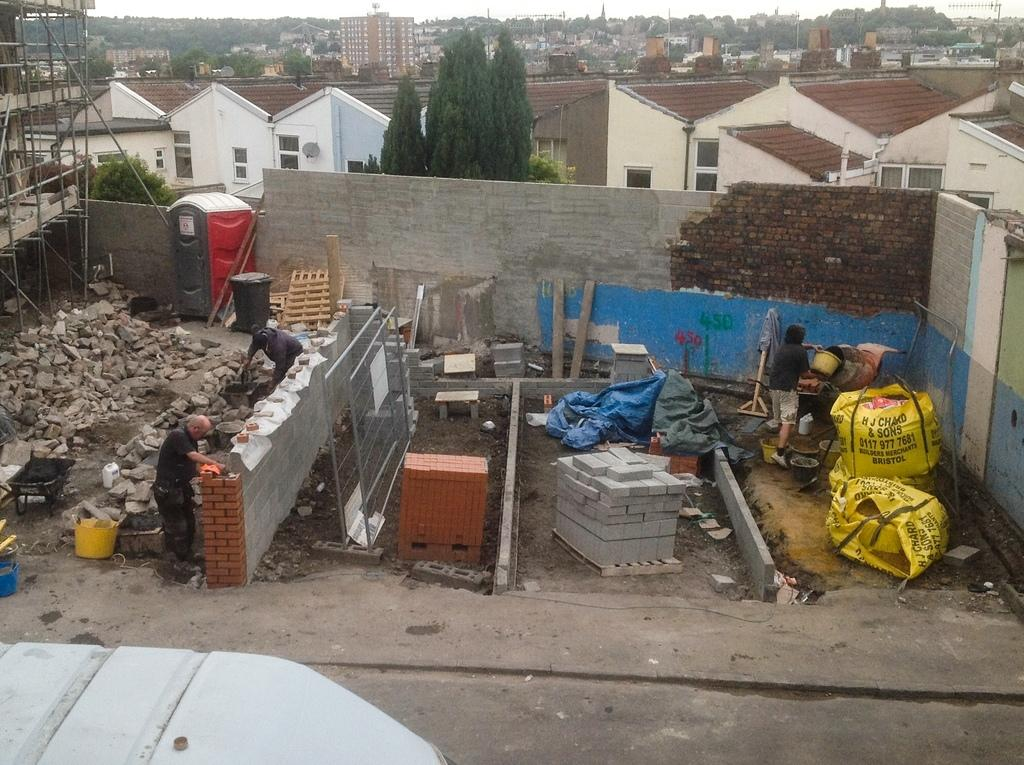What activity are the persons in the image engaged in? The persons in the image are constructing a house. What can be seen in the background of the image? There are houses and trees in the background of the image. What is the condition of the sky in the image? The sky is clear and visible in the background of the image. What is the rate of the branch growing in the image? There is no branch present in the image, so it is not possible to determine its growth rate. 